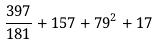<formula> <loc_0><loc_0><loc_500><loc_500>\frac { 3 9 7 } { 1 8 1 } + 1 5 7 + 7 9 ^ { 2 } + 1 7</formula> 